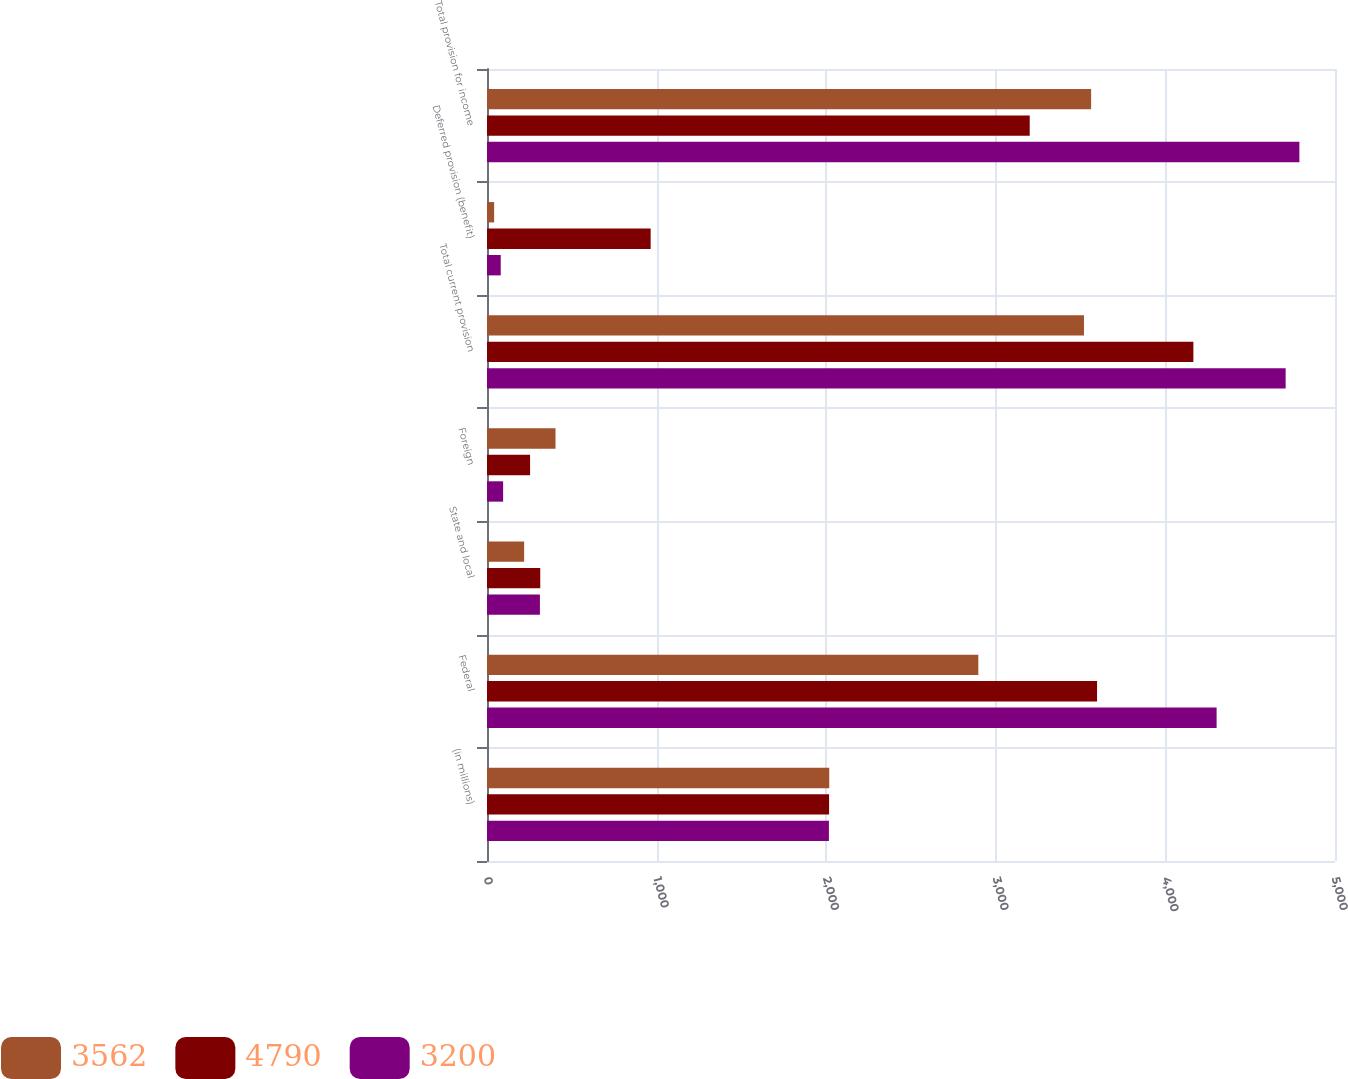<chart> <loc_0><loc_0><loc_500><loc_500><stacked_bar_chart><ecel><fcel>(in millions)<fcel>Federal<fcel>State and local<fcel>Foreign<fcel>Total current provision<fcel>Deferred provision (benefit)<fcel>Total provision for income<nl><fcel>3562<fcel>2018<fcel>2897<fcel>219<fcel>404<fcel>3520<fcel>42<fcel>3562<nl><fcel>4790<fcel>2017<fcel>3597<fcel>314<fcel>254<fcel>4165<fcel>965<fcel>3200<nl><fcel>3200<fcel>2016<fcel>4302<fcel>312<fcel>95<fcel>4709<fcel>81<fcel>4790<nl></chart> 